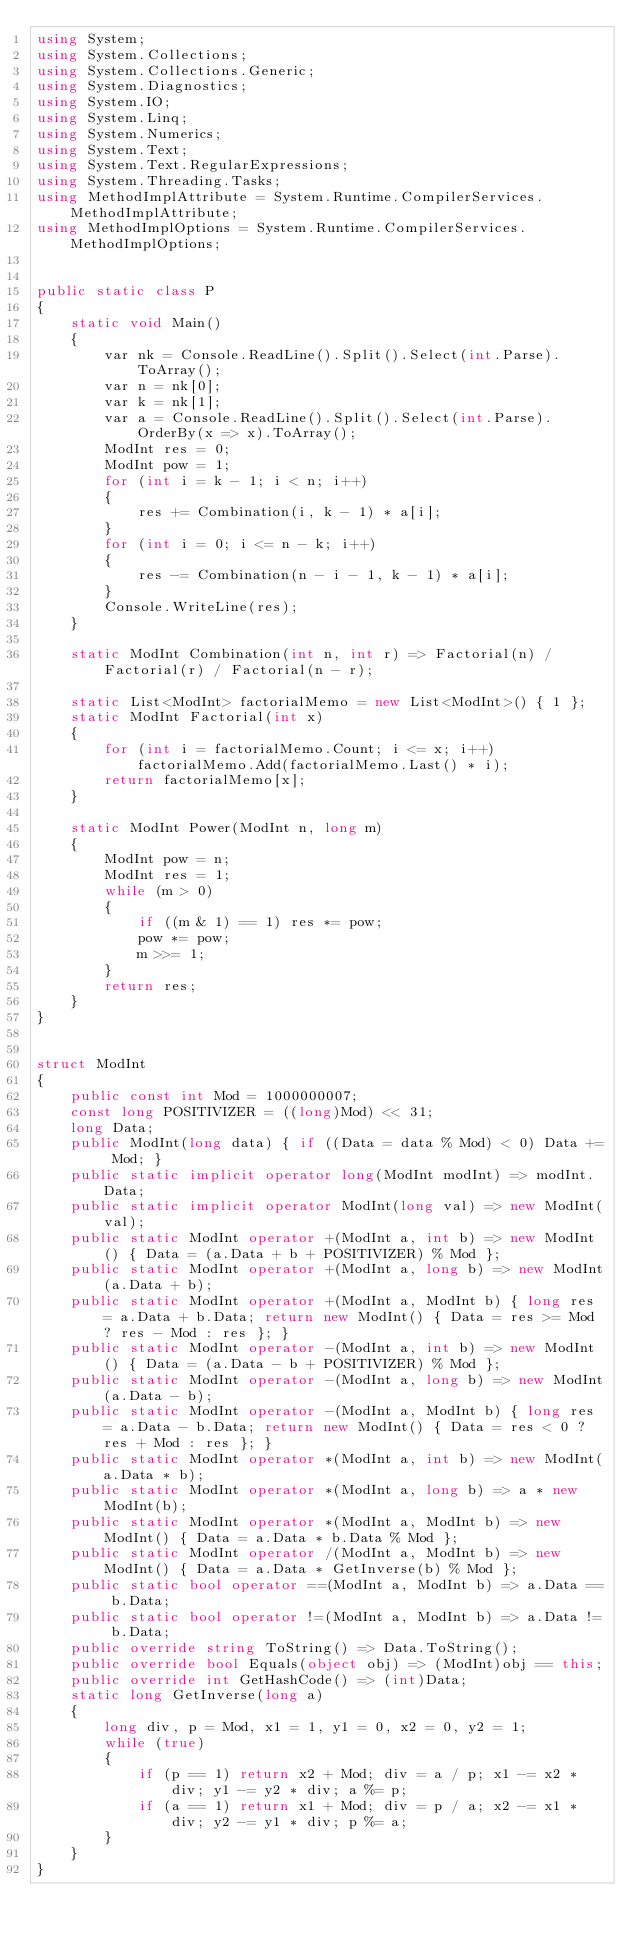<code> <loc_0><loc_0><loc_500><loc_500><_C#_>using System;
using System.Collections;
using System.Collections.Generic;
using System.Diagnostics;
using System.IO;
using System.Linq;
using System.Numerics;
using System.Text;
using System.Text.RegularExpressions;
using System.Threading.Tasks;
using MethodImplAttribute = System.Runtime.CompilerServices.MethodImplAttribute;
using MethodImplOptions = System.Runtime.CompilerServices.MethodImplOptions;


public static class P
{
    static void Main()
    {
        var nk = Console.ReadLine().Split().Select(int.Parse).ToArray();
        var n = nk[0];
        var k = nk[1];
        var a = Console.ReadLine().Split().Select(int.Parse).OrderBy(x => x).ToArray();
        ModInt res = 0;
        ModInt pow = 1;
        for (int i = k - 1; i < n; i++)
        {
            res += Combination(i, k - 1) * a[i];
        }
        for (int i = 0; i <= n - k; i++)
        {
            res -= Combination(n - i - 1, k - 1) * a[i];
        }
        Console.WriteLine(res);
    }

    static ModInt Combination(int n, int r) => Factorial(n) / Factorial(r) / Factorial(n - r);

    static List<ModInt> factorialMemo = new List<ModInt>() { 1 };
    static ModInt Factorial(int x)
    {
        for (int i = factorialMemo.Count; i <= x; i++) factorialMemo.Add(factorialMemo.Last() * i);
        return factorialMemo[x];
    }

    static ModInt Power(ModInt n, long m)
    {
        ModInt pow = n;
        ModInt res = 1;
        while (m > 0)
        {
            if ((m & 1) == 1) res *= pow;
            pow *= pow;
            m >>= 1;
        }
        return res;
    }
}


struct ModInt
{
    public const int Mod = 1000000007;
    const long POSITIVIZER = ((long)Mod) << 31;
    long Data;
    public ModInt(long data) { if ((Data = data % Mod) < 0) Data += Mod; }
    public static implicit operator long(ModInt modInt) => modInt.Data;
    public static implicit operator ModInt(long val) => new ModInt(val);
    public static ModInt operator +(ModInt a, int b) => new ModInt() { Data = (a.Data + b + POSITIVIZER) % Mod };
    public static ModInt operator +(ModInt a, long b) => new ModInt(a.Data + b);
    public static ModInt operator +(ModInt a, ModInt b) { long res = a.Data + b.Data; return new ModInt() { Data = res >= Mod ? res - Mod : res }; }
    public static ModInt operator -(ModInt a, int b) => new ModInt() { Data = (a.Data - b + POSITIVIZER) % Mod };
    public static ModInt operator -(ModInt a, long b) => new ModInt(a.Data - b);
    public static ModInt operator -(ModInt a, ModInt b) { long res = a.Data - b.Data; return new ModInt() { Data = res < 0 ? res + Mod : res }; }
    public static ModInt operator *(ModInt a, int b) => new ModInt(a.Data * b);
    public static ModInt operator *(ModInt a, long b) => a * new ModInt(b);
    public static ModInt operator *(ModInt a, ModInt b) => new ModInt() { Data = a.Data * b.Data % Mod };
    public static ModInt operator /(ModInt a, ModInt b) => new ModInt() { Data = a.Data * GetInverse(b) % Mod };
    public static bool operator ==(ModInt a, ModInt b) => a.Data == b.Data;
    public static bool operator !=(ModInt a, ModInt b) => a.Data != b.Data;
    public override string ToString() => Data.ToString();
    public override bool Equals(object obj) => (ModInt)obj == this;
    public override int GetHashCode() => (int)Data;
    static long GetInverse(long a)
    {
        long div, p = Mod, x1 = 1, y1 = 0, x2 = 0, y2 = 1;
        while (true)
        {
            if (p == 1) return x2 + Mod; div = a / p; x1 -= x2 * div; y1 -= y2 * div; a %= p;
            if (a == 1) return x1 + Mod; div = p / a; x2 -= x1 * div; y2 -= y1 * div; p %= a;
        }
    }
}
</code> 